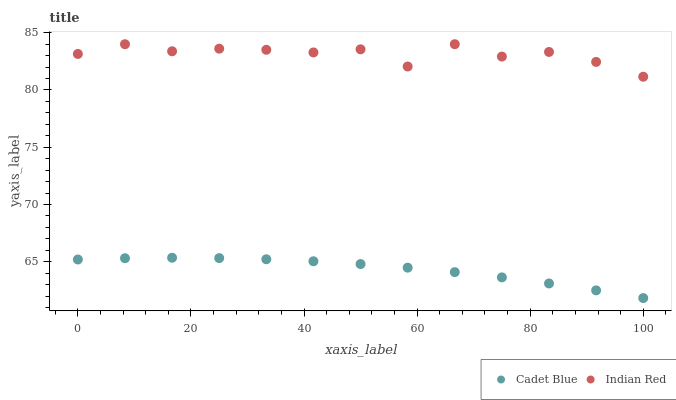Does Cadet Blue have the minimum area under the curve?
Answer yes or no. Yes. Does Indian Red have the maximum area under the curve?
Answer yes or no. Yes. Does Indian Red have the minimum area under the curve?
Answer yes or no. No. Is Cadet Blue the smoothest?
Answer yes or no. Yes. Is Indian Red the roughest?
Answer yes or no. Yes. Is Indian Red the smoothest?
Answer yes or no. No. Does Cadet Blue have the lowest value?
Answer yes or no. Yes. Does Indian Red have the lowest value?
Answer yes or no. No. Does Indian Red have the highest value?
Answer yes or no. Yes. Is Cadet Blue less than Indian Red?
Answer yes or no. Yes. Is Indian Red greater than Cadet Blue?
Answer yes or no. Yes. Does Cadet Blue intersect Indian Red?
Answer yes or no. No. 